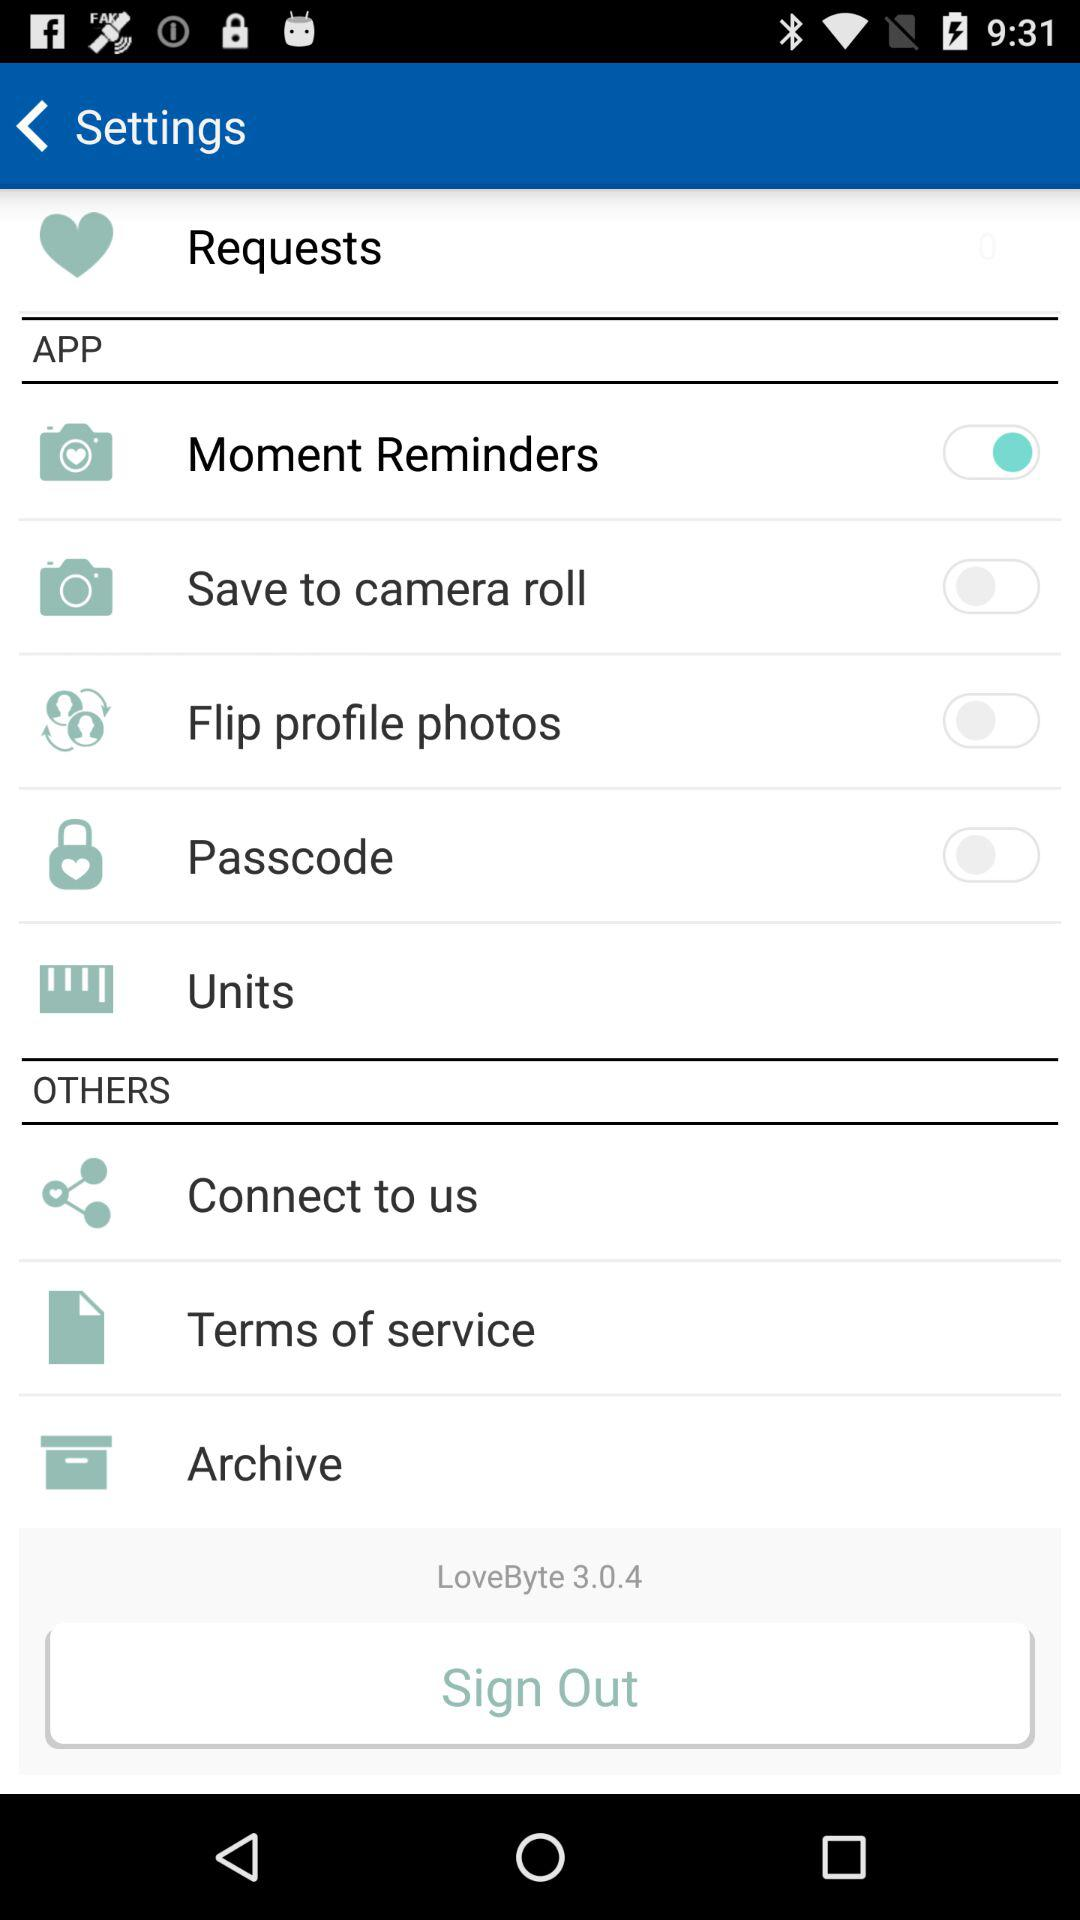What is the application name? The application name is "LoveByte". 